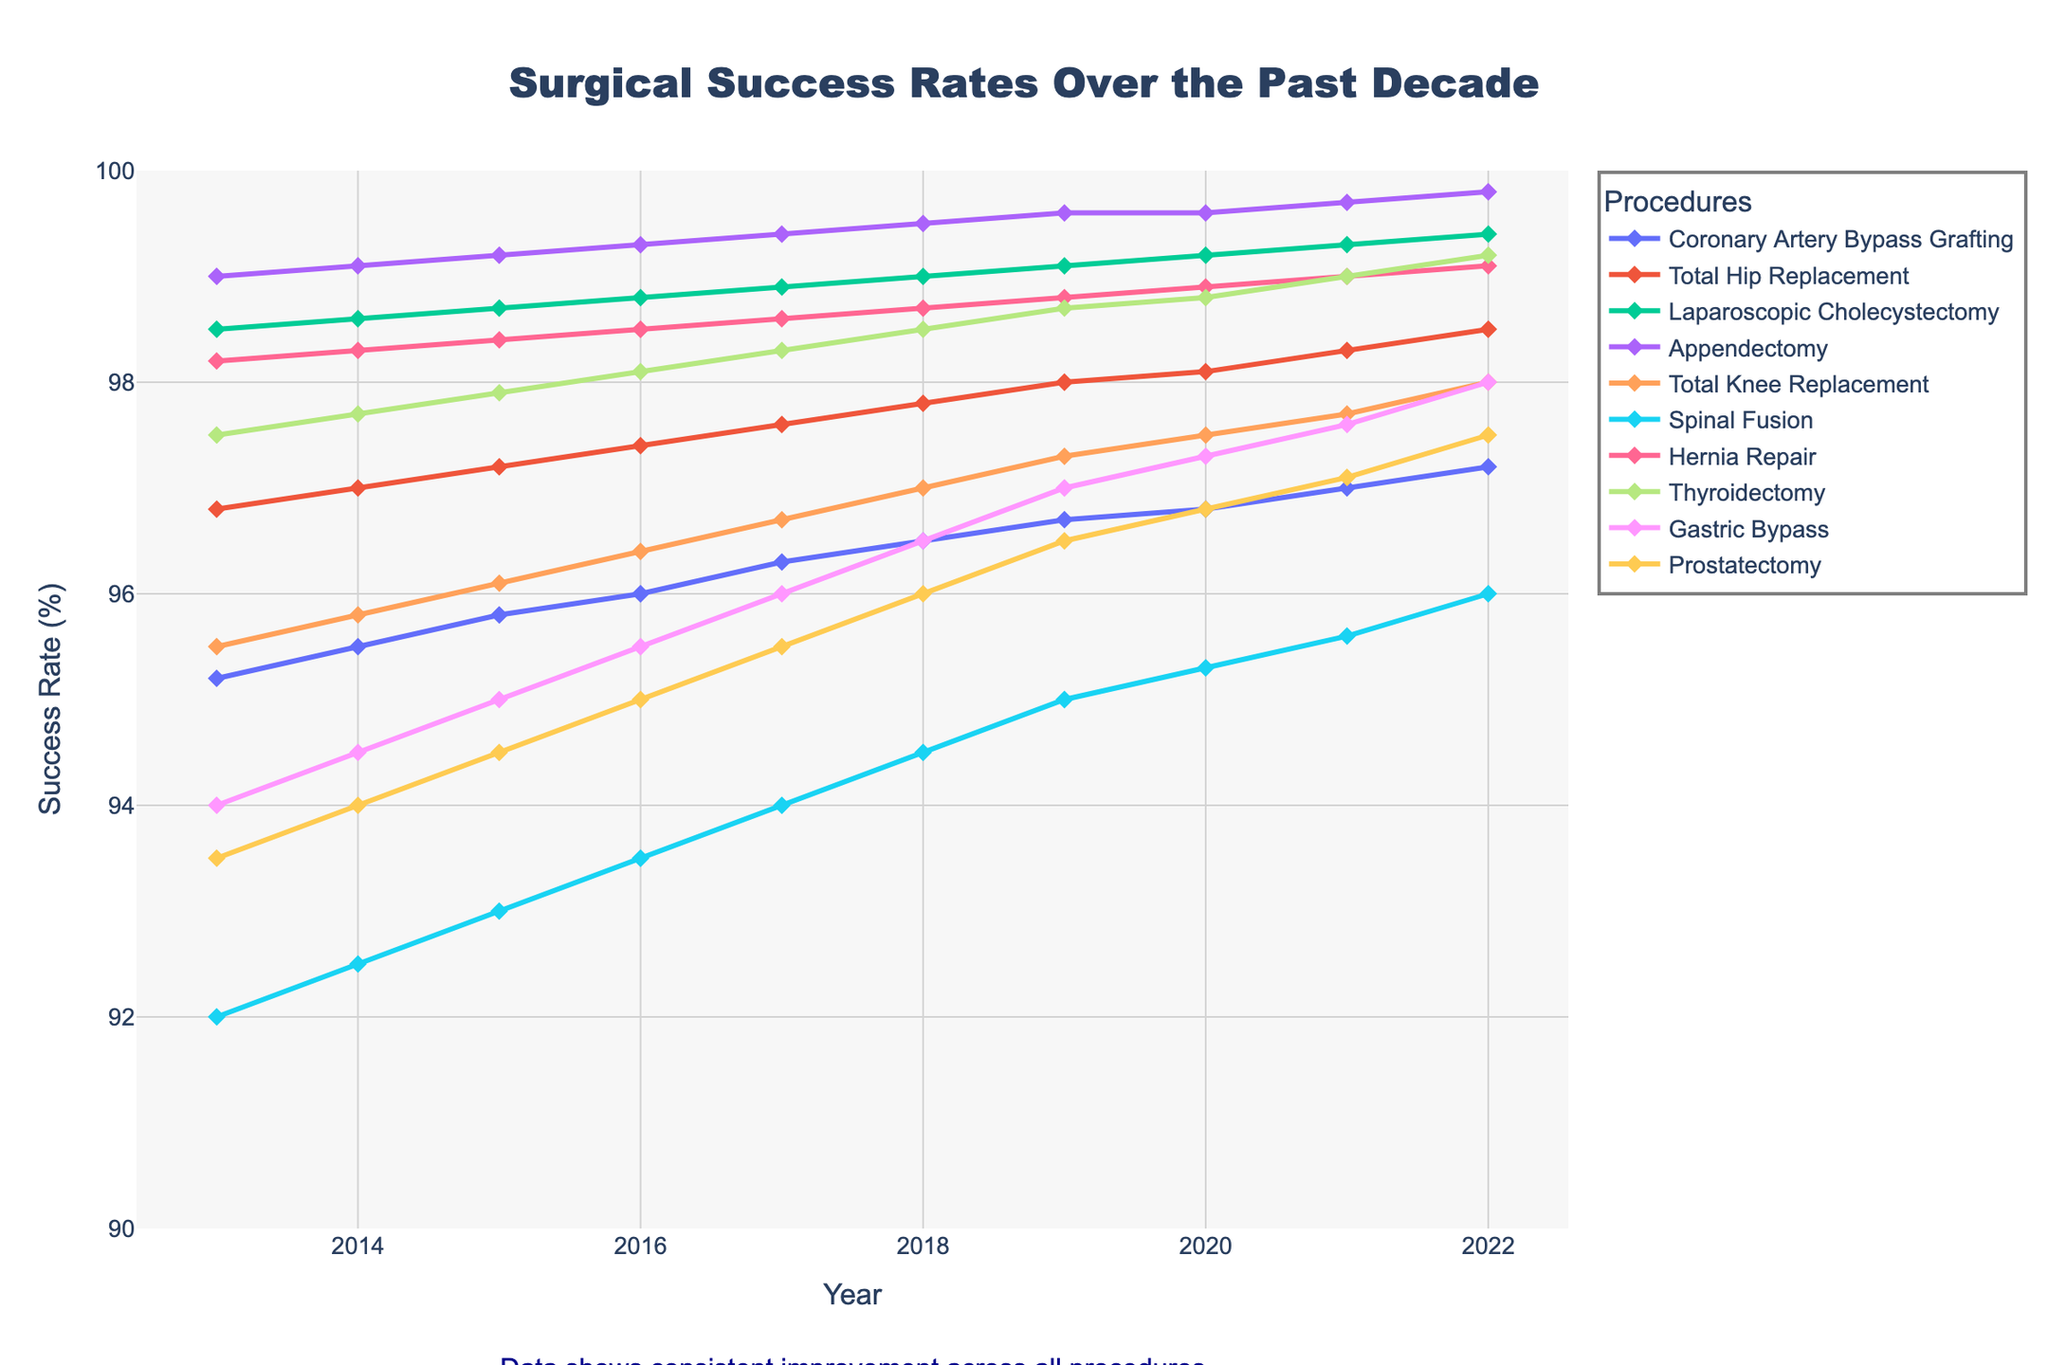What is the average success rate of Total Knee Replacement over the past decade? To find the average success rate of Total Knee Replacement, sum all the success rates from 2013 to 2022 and divide by the number of years. (95.5 + 95.8 + 96.1 + 96.4 + 96.7 + 97.0 + 97.3 + 97.5 + 97.7 + 98.0) / 10 = 967 / 10
Answer: 96.7 Which procedure had the highest success rate in 2022? By visually inspecting the figure, verify the end points of each line representing the success rates in 2022. The success rate for Laparoscopic Cholecystectomy appears to be the highest.
Answer: Laparoscopic Cholecystectomy What is the difference in success rates between Appendectomy and Coronary Artery Bypass Grafting in 2013? Check the initial points of both lines in 2013. Appendectomy has a success rate of 99.0 and Coronary Artery Bypass Grafting has 95.2. The difference is 99.0 - 95.2.
Answer: 3.8 Which procedure showed the greatest improvement in success rate from 2013 to 2022? Compare the change in success rates from 2013 to 2022 for each procedure. Look for the procedure with the highest difference. Spinal Fusion improved from 92.0 to 96.0, a difference of 4.0 which seems the greatest among all.
Answer: Spinal Fusion How many procedures had a success rate above 98% in 2019? Examine the graph at the year 2019 and count the number of procedures whose success rates exceeded 98%. Laparoscopic Cholecystectomy, Appendectomy, Thyroidectomy, Hernia Repair, and Total Hip Replacement are all above 98%.
Answer: 5 In which year did Total Hip Replacement first exceed a 98% success rate? Check the line for Total Hip Replacement for the first year it crosses the 98% mark. This happens in 2019.
Answer: 2019 What is the average increase in success rate per year for Gastric Bypass from 2013 to 2022? Calculate the total increase over the period 2013 to 2022 by subtracting the start rate from the end rate. Then, divide by the number of years. (98.0 - 94.0) / 10 = 4.0 / 10
Answer: 0.4 Is the trend of the success rate for Thyroidectomy increasing, decreasing, or stable? Observe the line representing Thyroidectomy success rates from 2013 to 2022. The line consistently rises indicating an increasing trend.
Answer: Increasing Which procedure had a success rate closest to 97% in 2022? Find the procedures' success rates for 2022 and identify the one nearest to 97%. Coronary Artery Bypass Grafting has a success rate of 97.2%, which is the closest.
Answer: Coronary Artery Bypass Grafting 